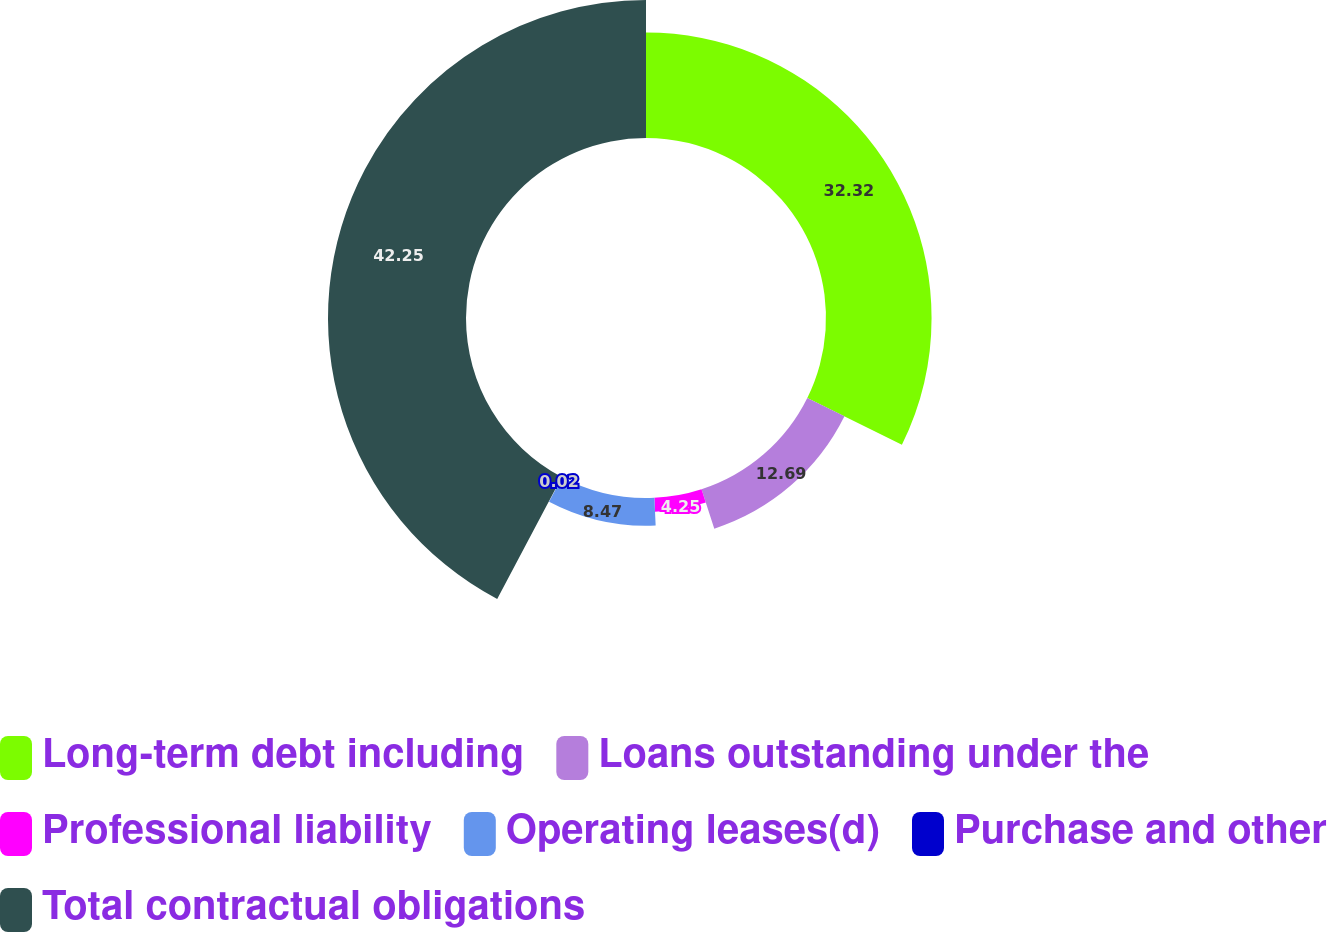Convert chart to OTSL. <chart><loc_0><loc_0><loc_500><loc_500><pie_chart><fcel>Long-term debt including<fcel>Loans outstanding under the<fcel>Professional liability<fcel>Operating leases(d)<fcel>Purchase and other<fcel>Total contractual obligations<nl><fcel>32.32%<fcel>12.69%<fcel>4.25%<fcel>8.47%<fcel>0.02%<fcel>42.25%<nl></chart> 